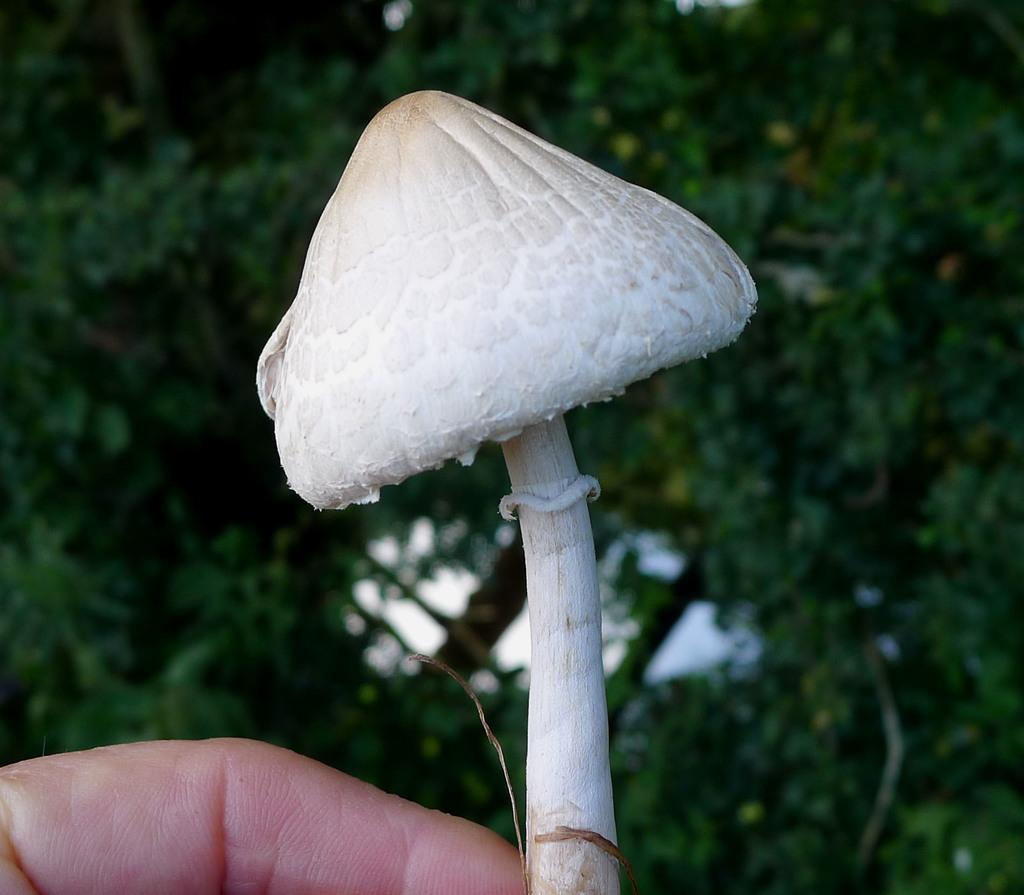What is being held in the image? The hand in the image is holding a mushroom. Can you describe the background of the image? There are trees in the background of the image. What type of snail can be seen crawling on the mushroom in the image? There is no snail present in the image; it only shows a hand holding a mushroom and trees in the background. 